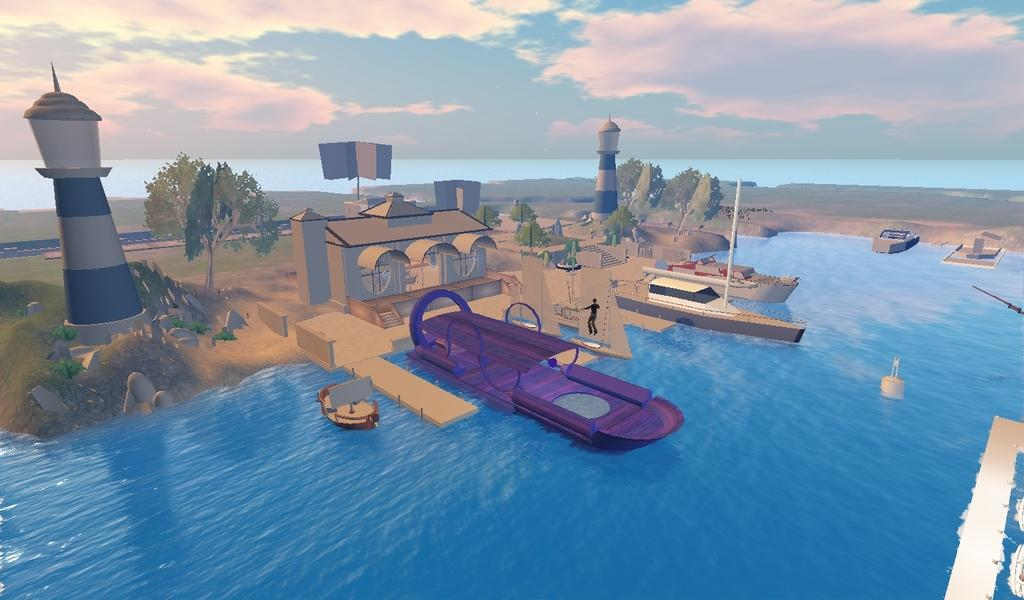What type of image is depicted in the picture? There is a graphical image in the picture. What can be seen on the water in the image? There are boats on the water in the image. What is visible in the background of the image? There are trees, towers, a building, and clouds visible in the background of the image. What type of grain is being harvested in the image? There is no grain present in the image; it features a graphical image with boats on the water and various structures and natural elements in the background. What kind of error is visible in the image? There is no error present in the image; it is a clear and accurate representation of the scene. 